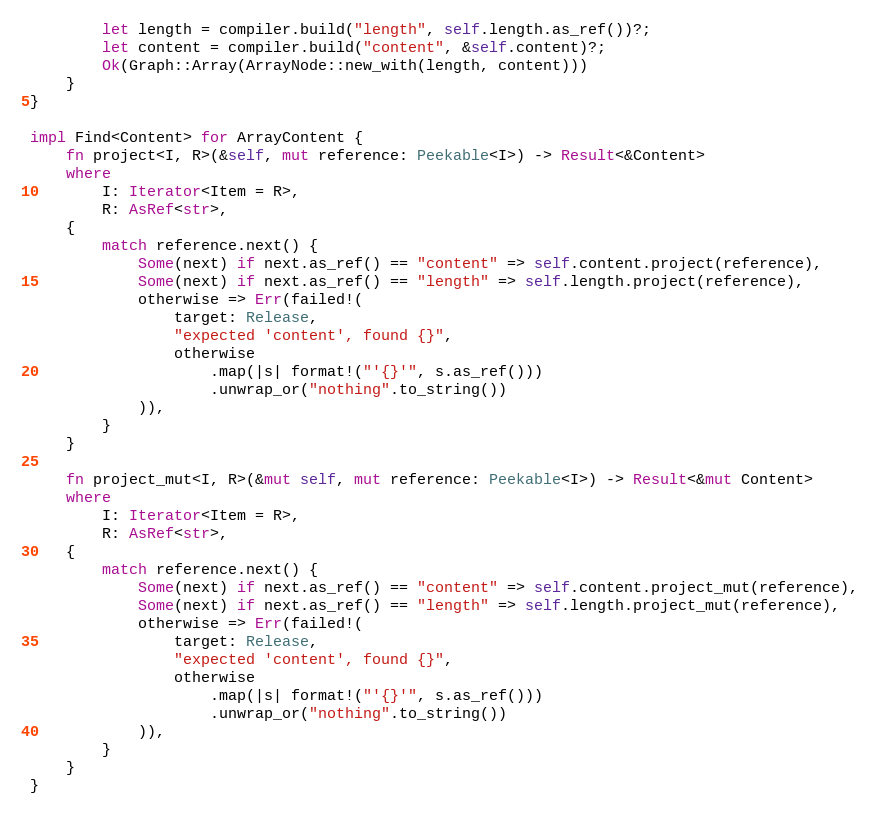Convert code to text. <code><loc_0><loc_0><loc_500><loc_500><_Rust_>        let length = compiler.build("length", self.length.as_ref())?;
        let content = compiler.build("content", &self.content)?;
        Ok(Graph::Array(ArrayNode::new_with(length, content)))
    }
}

impl Find<Content> for ArrayContent {
    fn project<I, R>(&self, mut reference: Peekable<I>) -> Result<&Content>
    where
        I: Iterator<Item = R>,
        R: AsRef<str>,
    {
        match reference.next() {
            Some(next) if next.as_ref() == "content" => self.content.project(reference),
            Some(next) if next.as_ref() == "length" => self.length.project(reference),
            otherwise => Err(failed!(
                target: Release,
                "expected 'content', found {}",
                otherwise
                    .map(|s| format!("'{}'", s.as_ref()))
                    .unwrap_or("nothing".to_string())
            )),
        }
    }

    fn project_mut<I, R>(&mut self, mut reference: Peekable<I>) -> Result<&mut Content>
    where
        I: Iterator<Item = R>,
        R: AsRef<str>,
    {
        match reference.next() {
            Some(next) if next.as_ref() == "content" => self.content.project_mut(reference),
            Some(next) if next.as_ref() == "length" => self.length.project_mut(reference),
            otherwise => Err(failed!(
                target: Release,
                "expected 'content', found {}",
                otherwise
                    .map(|s| format!("'{}'", s.as_ref()))
                    .unwrap_or("nothing".to_string())
            )),
        }
    }
}
</code> 